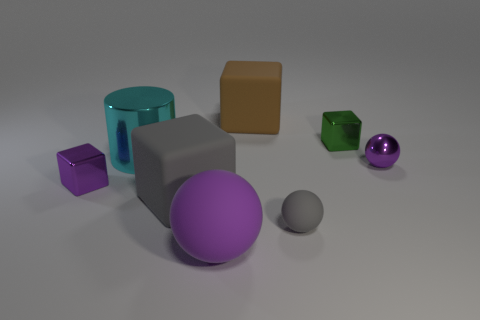Subtract all tiny purple metal blocks. How many blocks are left? 3 Subtract all purple cylinders. How many purple balls are left? 2 Subtract all purple cubes. How many cubes are left? 3 Add 1 big yellow balls. How many objects exist? 9 Subtract all spheres. How many objects are left? 5 Subtract all cyan cubes. Subtract all gray balls. How many cubes are left? 4 Subtract all large matte blocks. Subtract all tiny green blocks. How many objects are left? 5 Add 8 cyan cylinders. How many cyan cylinders are left? 9 Add 3 brown objects. How many brown objects exist? 4 Subtract 1 green blocks. How many objects are left? 7 